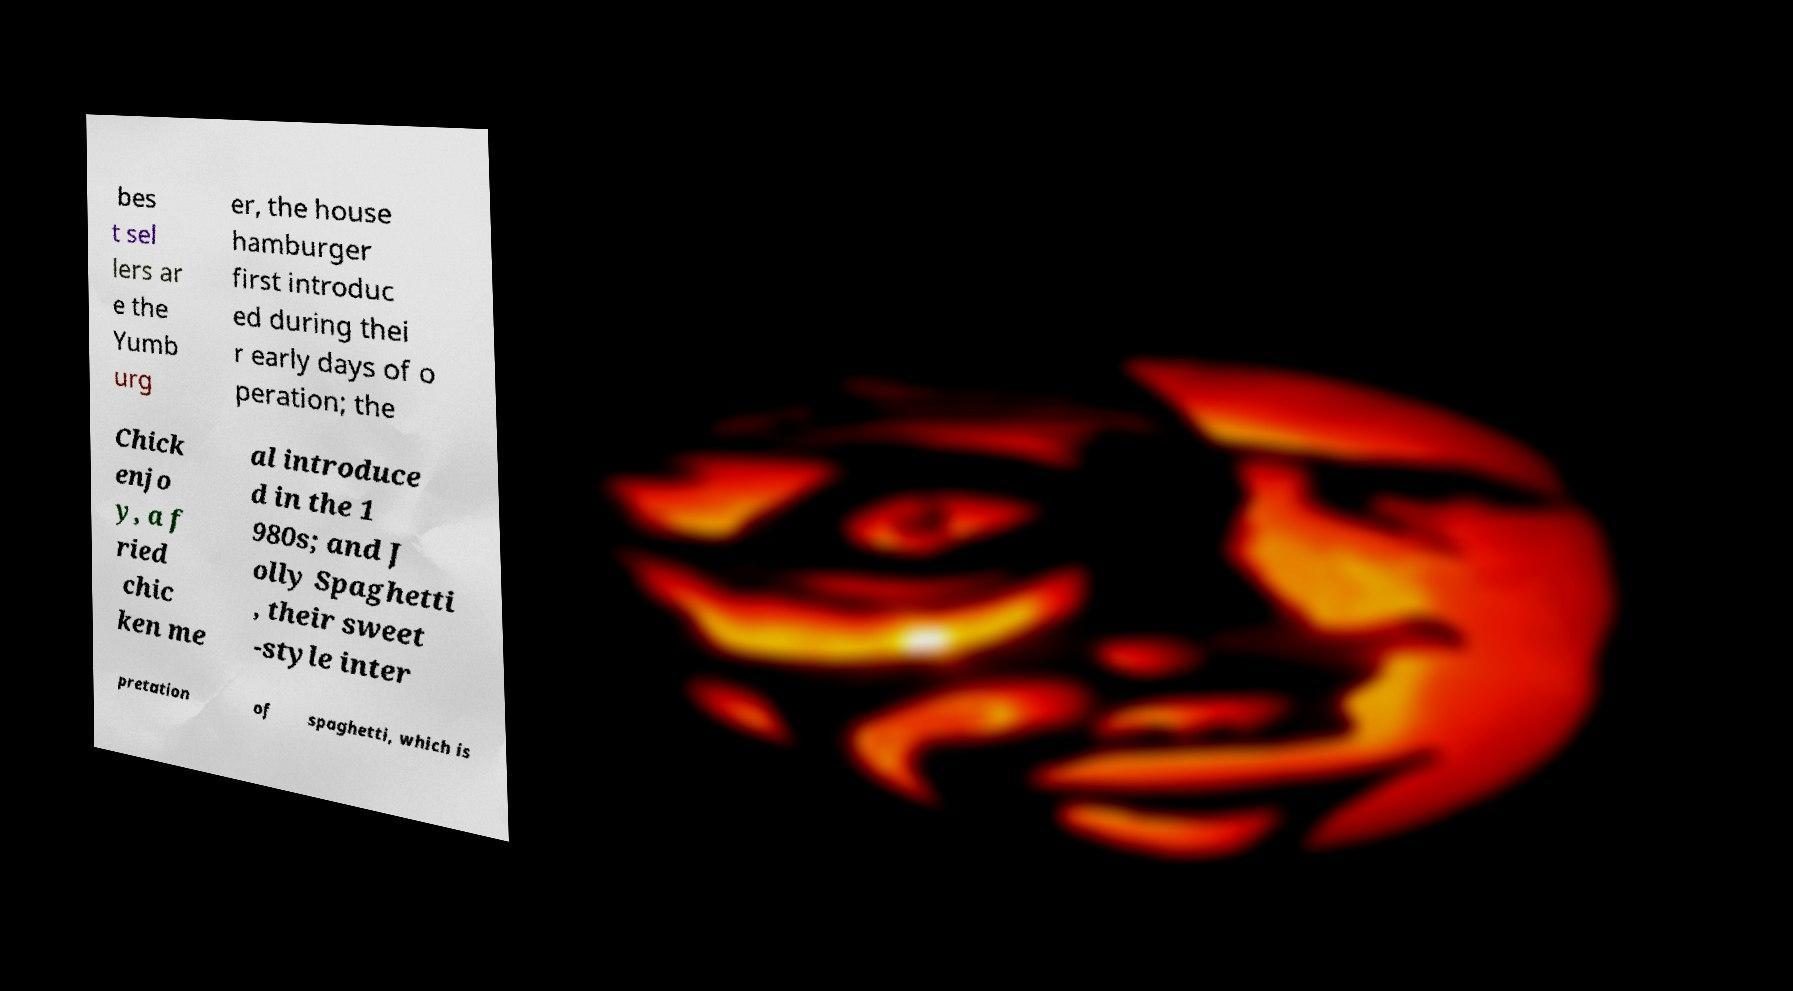Could you extract and type out the text from this image? bes t sel lers ar e the Yumb urg er, the house hamburger first introduc ed during thei r early days of o peration; the Chick enjo y, a f ried chic ken me al introduce d in the 1 980s; and J olly Spaghetti , their sweet -style inter pretation of spaghetti, which is 